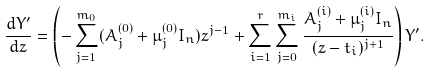<formula> <loc_0><loc_0><loc_500><loc_500>\frac { d Y ^ { \prime } } { d z } = \left ( - \sum _ { j = 1 } ^ { m _ { 0 } } ( A _ { j } ^ { ( 0 ) } + \mu ^ { ( 0 ) } _ { j } I _ { n } ) z ^ { j - 1 } + \sum _ { i = 1 } ^ { r } \sum _ { j = 0 } ^ { m _ { i } } \frac { A _ { j } ^ { ( i ) } + \mu ^ { ( i ) } _ { j } I _ { n } } { ( z - t _ { i } ) ^ { j + 1 } } \right ) Y ^ { \prime } .</formula> 